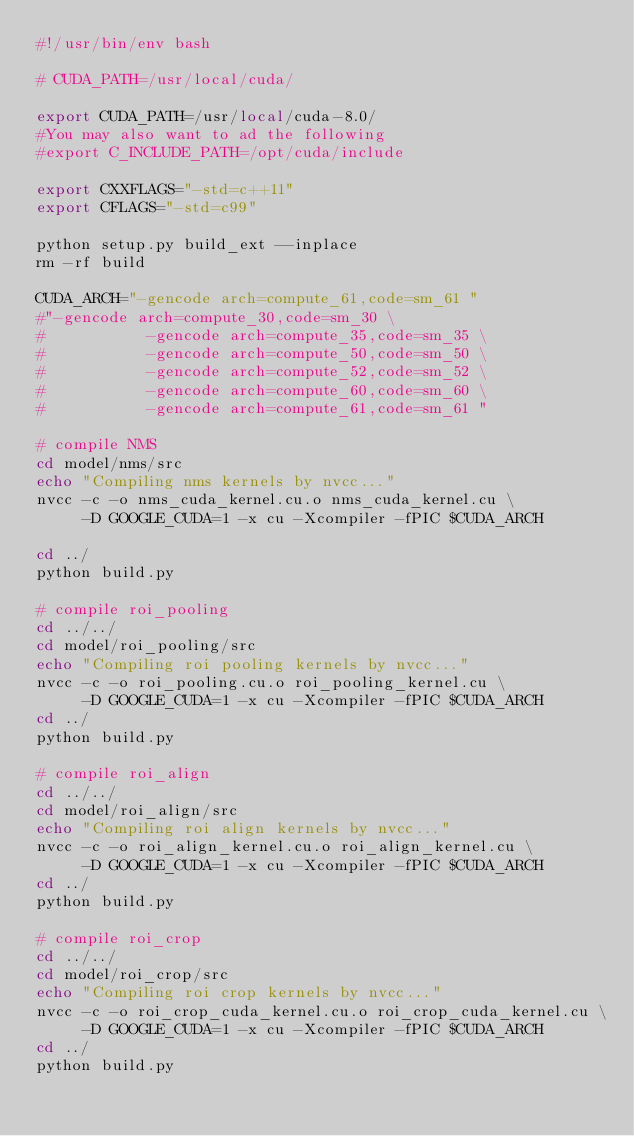<code> <loc_0><loc_0><loc_500><loc_500><_Bash_>#!/usr/bin/env bash

# CUDA_PATH=/usr/local/cuda/

export CUDA_PATH=/usr/local/cuda-8.0/
#You may also want to ad the following
#export C_INCLUDE_PATH=/opt/cuda/include

export CXXFLAGS="-std=c++11"
export CFLAGS="-std=c99"

python setup.py build_ext --inplace
rm -rf build

CUDA_ARCH="-gencode arch=compute_61,code=sm_61 "
#"-gencode arch=compute_30,code=sm_30 \
#           -gencode arch=compute_35,code=sm_35 \
#           -gencode arch=compute_50,code=sm_50 \
#           -gencode arch=compute_52,code=sm_52 \
#           -gencode arch=compute_60,code=sm_60 \
#           -gencode arch=compute_61,code=sm_61 "

# compile NMS
cd model/nms/src
echo "Compiling nms kernels by nvcc..."
nvcc -c -o nms_cuda_kernel.cu.o nms_cuda_kernel.cu \
	 -D GOOGLE_CUDA=1 -x cu -Xcompiler -fPIC $CUDA_ARCH

cd ../
python build.py

# compile roi_pooling
cd ../../
cd model/roi_pooling/src
echo "Compiling roi pooling kernels by nvcc..."
nvcc -c -o roi_pooling.cu.o roi_pooling_kernel.cu \
	 -D GOOGLE_CUDA=1 -x cu -Xcompiler -fPIC $CUDA_ARCH
cd ../
python build.py

# compile roi_align
cd ../../
cd model/roi_align/src
echo "Compiling roi align kernels by nvcc..."
nvcc -c -o roi_align_kernel.cu.o roi_align_kernel.cu \
	 -D GOOGLE_CUDA=1 -x cu -Xcompiler -fPIC $CUDA_ARCH
cd ../
python build.py

# compile roi_crop
cd ../../
cd model/roi_crop/src
echo "Compiling roi crop kernels by nvcc..."
nvcc -c -o roi_crop_cuda_kernel.cu.o roi_crop_cuda_kernel.cu \
	 -D GOOGLE_CUDA=1 -x cu -Xcompiler -fPIC $CUDA_ARCH
cd ../
python build.py
</code> 